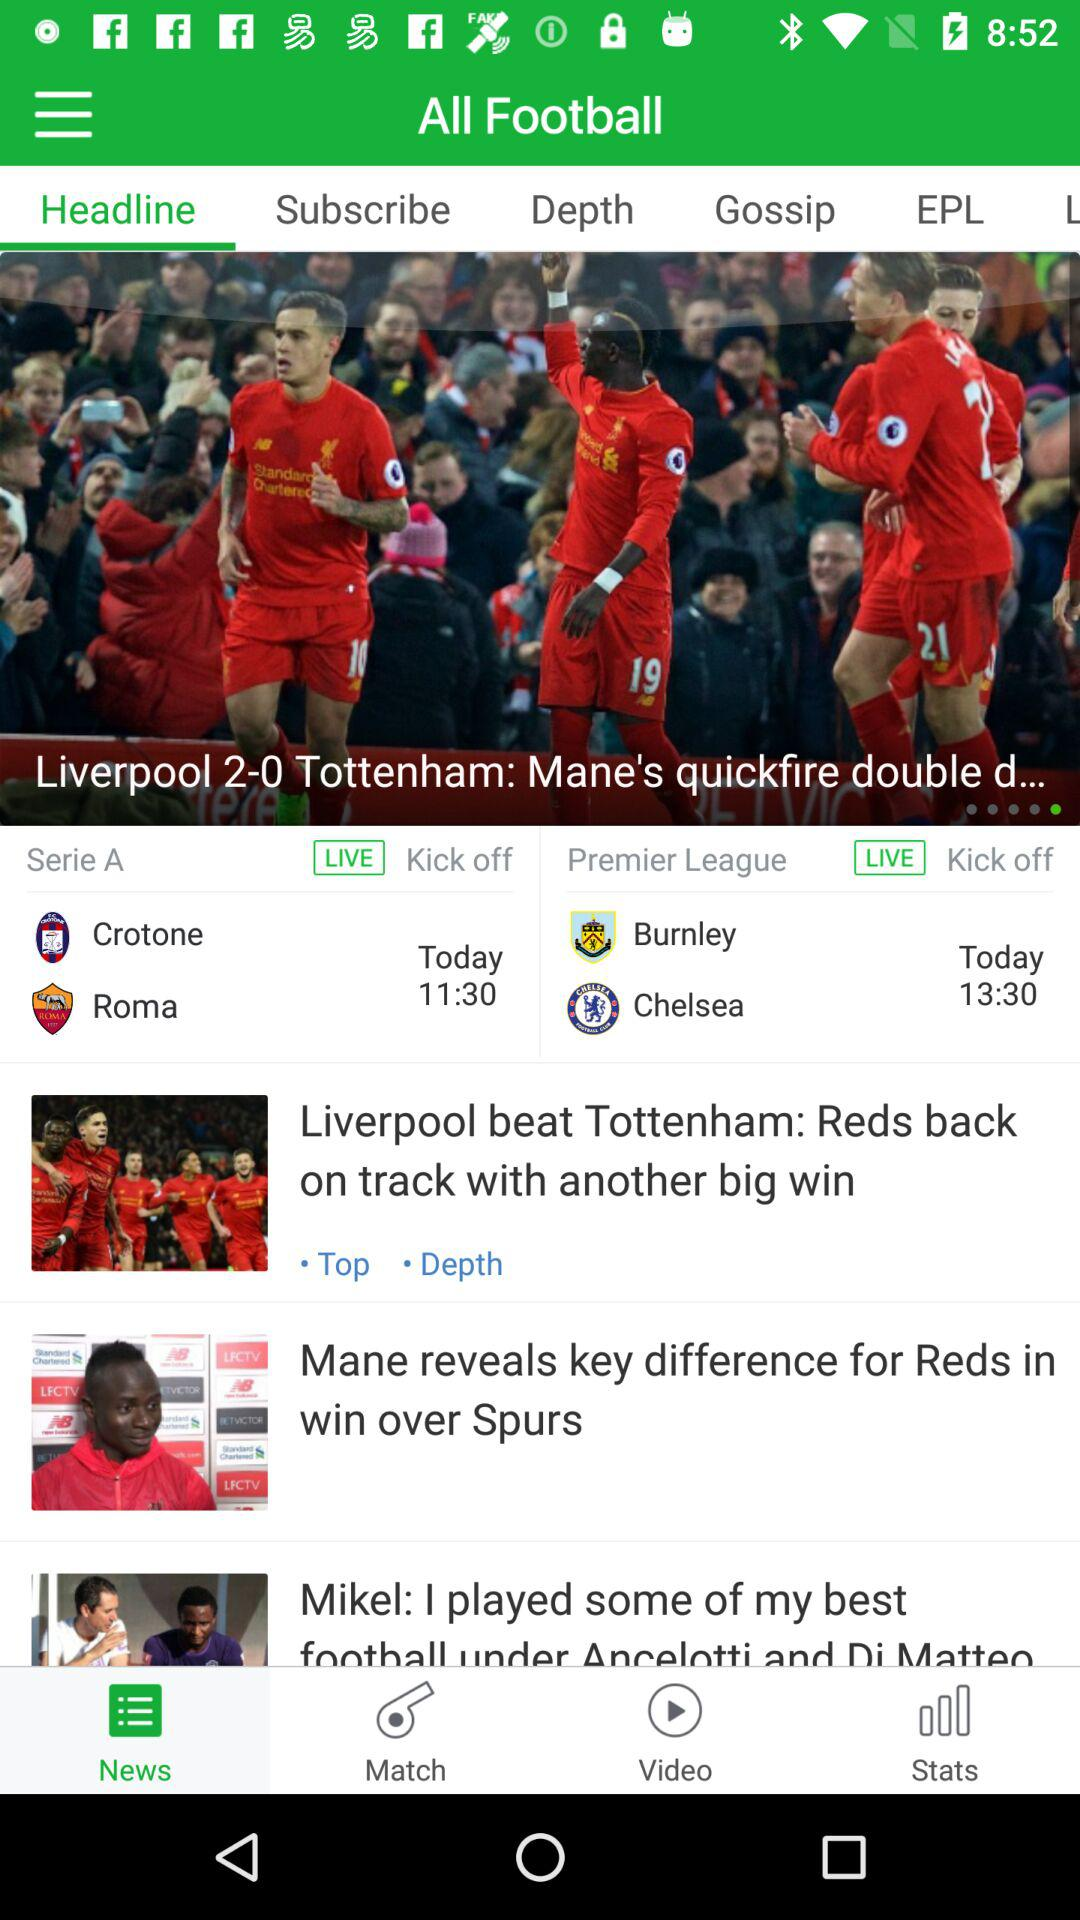How many more goals did Liverpool score than Burnley?
Answer the question using a single word or phrase. 2 